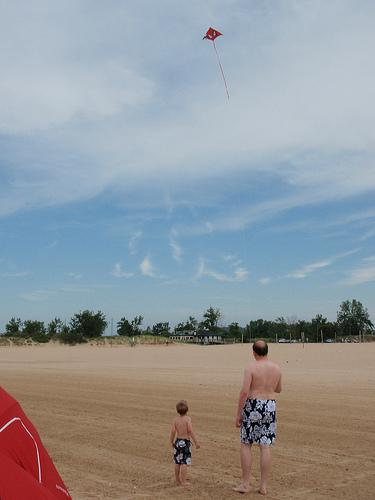Question: what are the people doing?
Choices:
A. Flying a kite.
B. Eating.
C. Playing soccer.
D. Laughing.
Answer with the letter. Answer: A Question: why is the kite in the sky?
Choices:
A. Competition.
B. Advertisement.
C. It's flying.
D. Entertain child.
Answer with the letter. Answer: C 